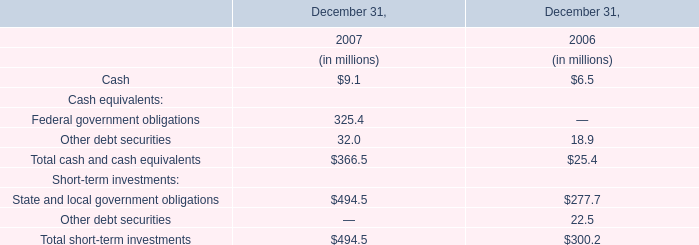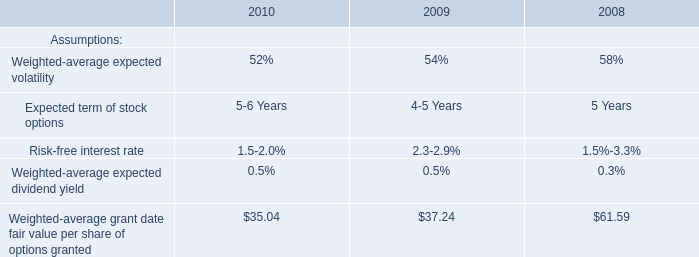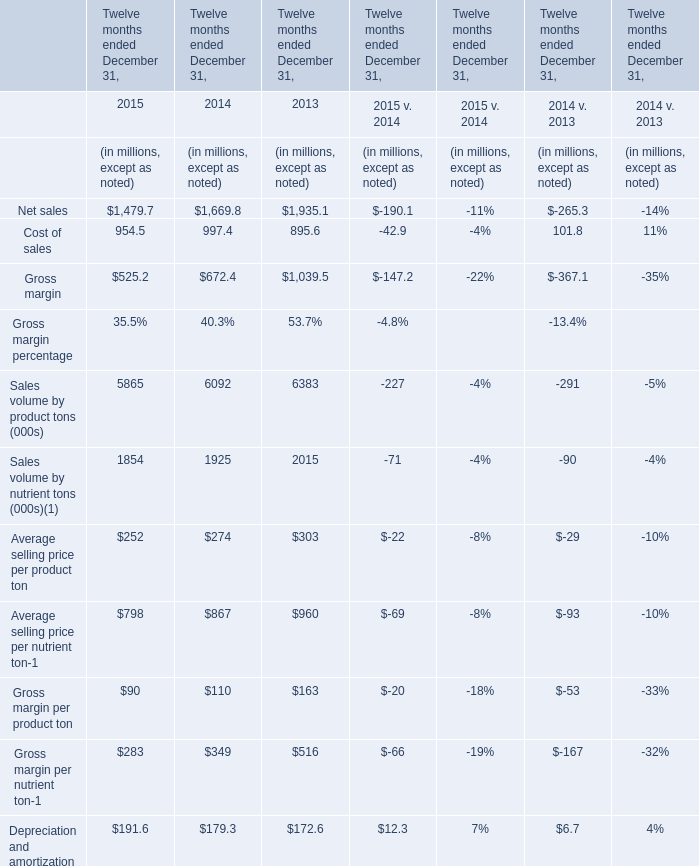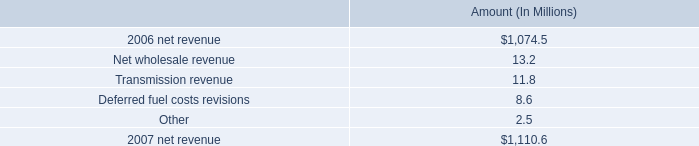What was the average of Cost of sales in 2015, 2014, and 2013? (in millions) 
Computations: (((954.5 + 997.4) + 895.6) / 3)
Answer: 949.16667. 